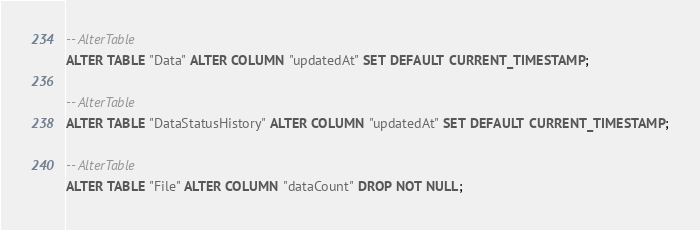Convert code to text. <code><loc_0><loc_0><loc_500><loc_500><_SQL_>-- AlterTable
ALTER TABLE "Data" ALTER COLUMN "updatedAt" SET DEFAULT CURRENT_TIMESTAMP;

-- AlterTable
ALTER TABLE "DataStatusHistory" ALTER COLUMN "updatedAt" SET DEFAULT CURRENT_TIMESTAMP;

-- AlterTable
ALTER TABLE "File" ALTER COLUMN "dataCount" DROP NOT NULL;
</code> 